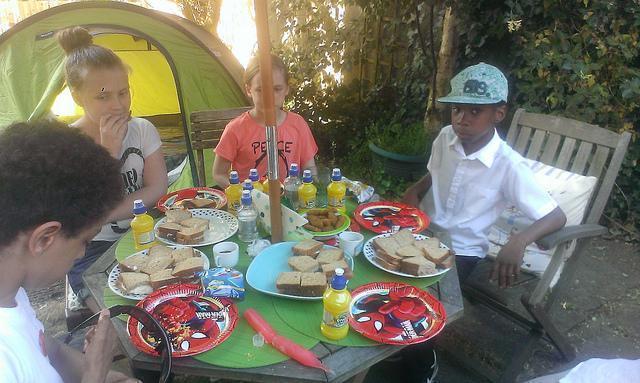What comic brand owns the franchise depicted here?
Select the correct answer and articulate reasoning with the following format: 'Answer: answer
Rationale: rationale.'
Options: Pixar, dc, disney, marvel. Answer: marvel.
Rationale: Spiderman is on the plates. 